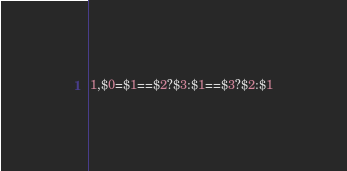<code> <loc_0><loc_0><loc_500><loc_500><_Awk_>1,$0=$1==$2?$3:$1==$3?$2:$1</code> 